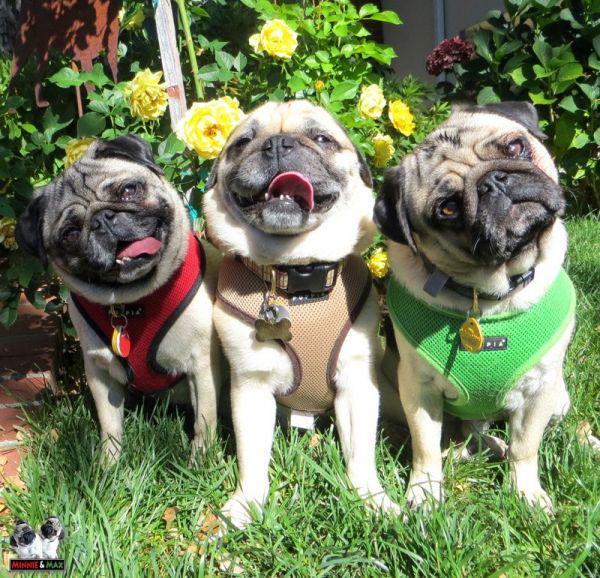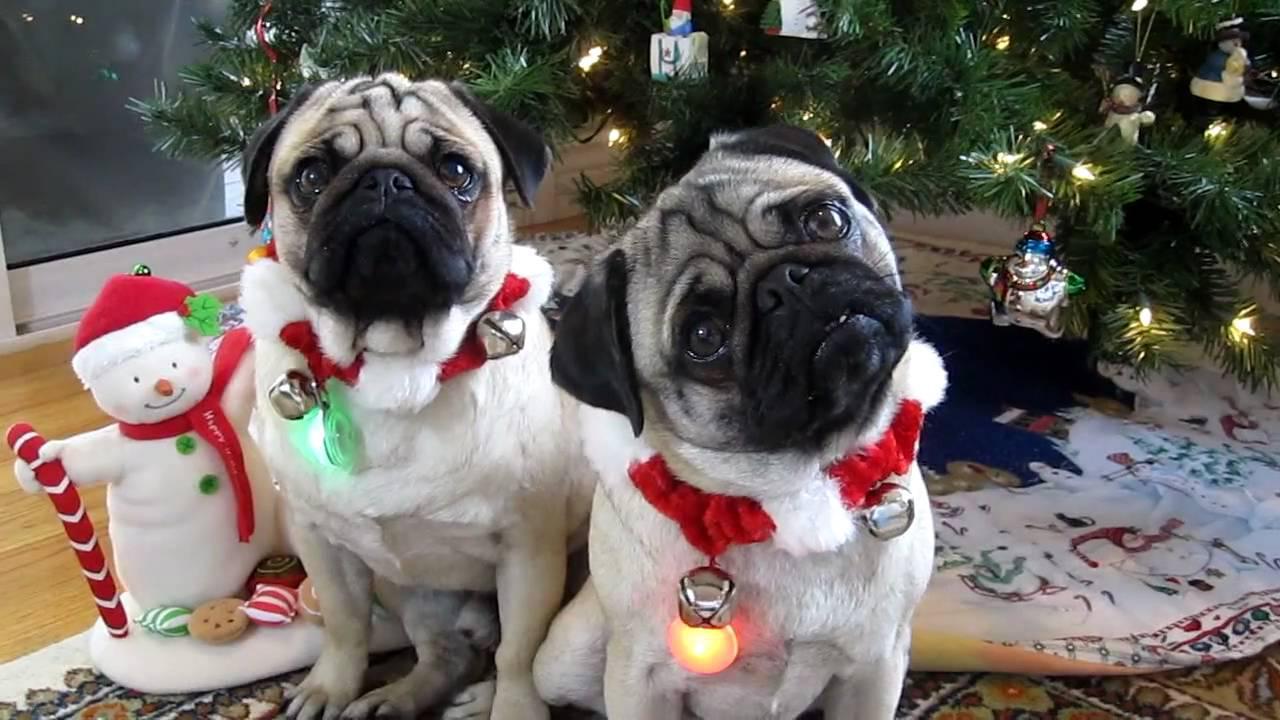The first image is the image on the left, the second image is the image on the right. Assess this claim about the two images: "A total of five dogs are shown, and all dogs are wearing some type of attire other than an ordinary dog collar.". Correct or not? Answer yes or no. Yes. The first image is the image on the left, the second image is the image on the right. Evaluate the accuracy of this statement regarding the images: "All the dogs in the images are tan pugs.". Is it true? Answer yes or no. Yes. 